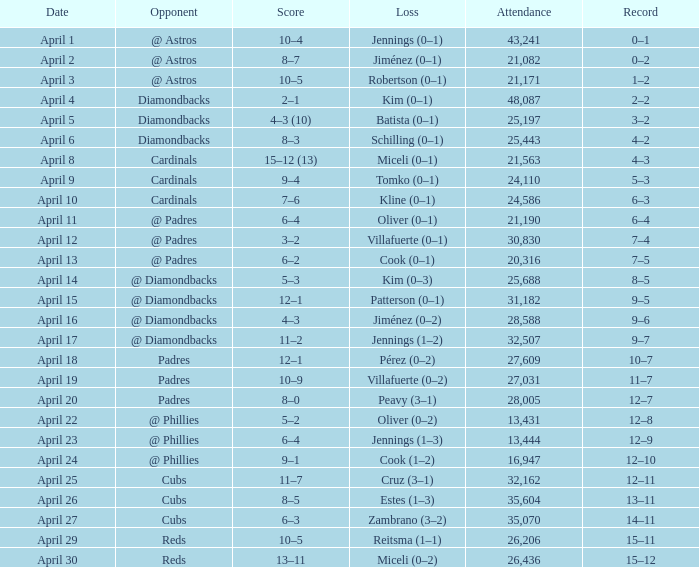Who is the opponent on april 16? @ Diamondbacks. 